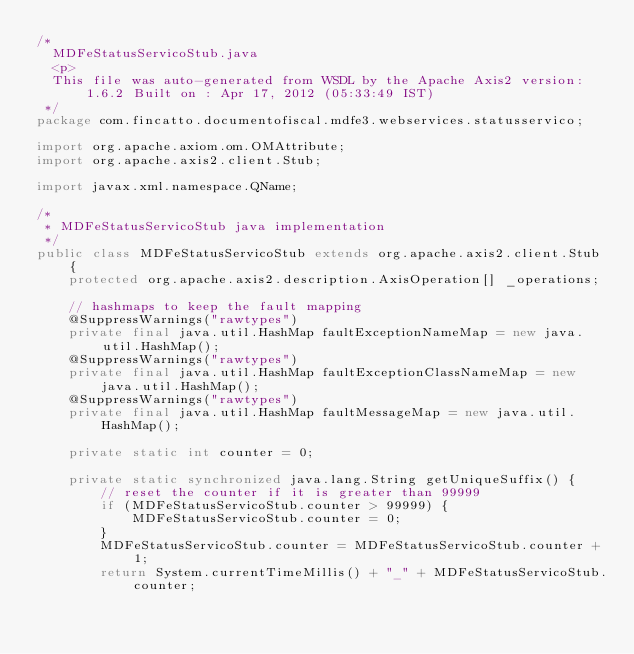<code> <loc_0><loc_0><loc_500><loc_500><_Java_>/*
  MDFeStatusServicoStub.java
  <p>
  This file was auto-generated from WSDL by the Apache Axis2 version: 1.6.2 Built on : Apr 17, 2012 (05:33:49 IST)
 */
package com.fincatto.documentofiscal.mdfe3.webservices.statusservico;

import org.apache.axiom.om.OMAttribute;
import org.apache.axis2.client.Stub;

import javax.xml.namespace.QName;

/*
 * MDFeStatusServicoStub java implementation
 */
public class MDFeStatusServicoStub extends org.apache.axis2.client.Stub {
    protected org.apache.axis2.description.AxisOperation[] _operations;

    // hashmaps to keep the fault mapping
    @SuppressWarnings("rawtypes")
    private final java.util.HashMap faultExceptionNameMap = new java.util.HashMap();
    @SuppressWarnings("rawtypes")
    private final java.util.HashMap faultExceptionClassNameMap = new java.util.HashMap();
    @SuppressWarnings("rawtypes")
    private final java.util.HashMap faultMessageMap = new java.util.HashMap();

    private static int counter = 0;

    private static synchronized java.lang.String getUniqueSuffix() {
        // reset the counter if it is greater than 99999
        if (MDFeStatusServicoStub.counter > 99999) {
            MDFeStatusServicoStub.counter = 0;
        }
        MDFeStatusServicoStub.counter = MDFeStatusServicoStub.counter + 1;
        return System.currentTimeMillis() + "_" + MDFeStatusServicoStub.counter;</code> 